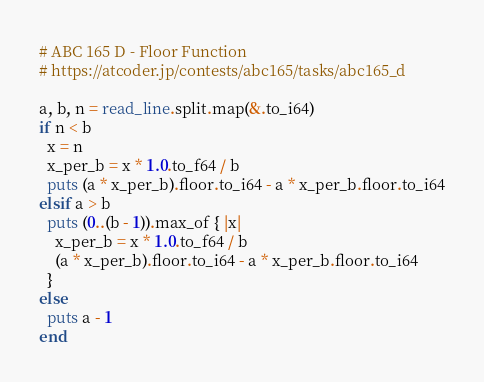Convert code to text. <code><loc_0><loc_0><loc_500><loc_500><_Crystal_># ABC 165 D - Floor Function
# https://atcoder.jp/contests/abc165/tasks/abc165_d

a, b, n = read_line.split.map(&.to_i64)
if n < b
  x = n
  x_per_b = x * 1.0.to_f64 / b
  puts (a * x_per_b).floor.to_i64 - a * x_per_b.floor.to_i64
elsif a > b
  puts (0..(b - 1)).max_of { |x|
    x_per_b = x * 1.0.to_f64 / b
    (a * x_per_b).floor.to_i64 - a * x_per_b.floor.to_i64
  }
else
  puts a - 1
end
</code> 